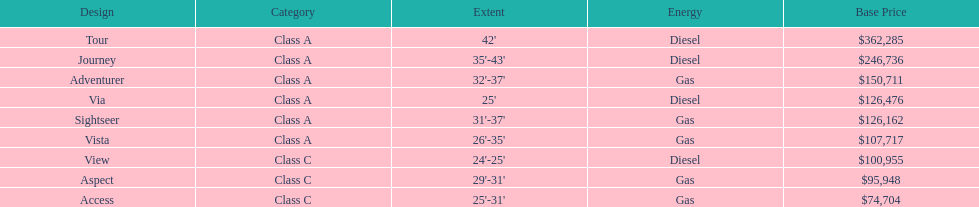How many models are available in lengths longer than 30 feet? 7. 